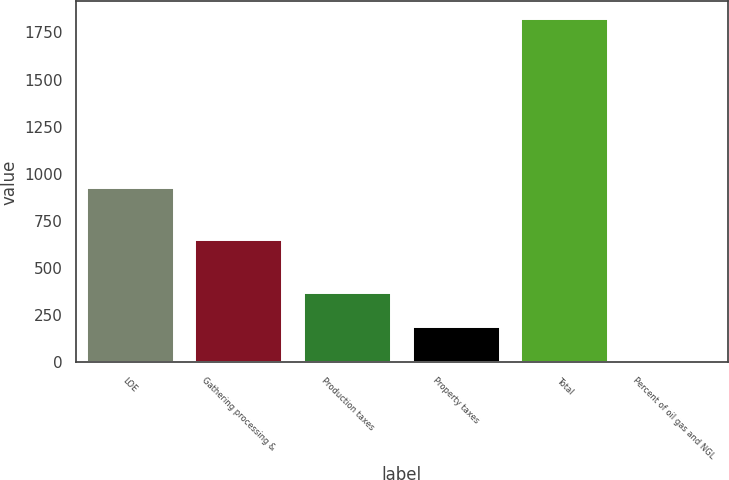Convert chart to OTSL. <chart><loc_0><loc_0><loc_500><loc_500><bar_chart><fcel>LOE<fcel>Gathering processing &<fcel>Production taxes<fcel>Property taxes<fcel>Total<fcel>Percent of oil gas and NGL<nl><fcel>927<fcel>647<fcel>367.64<fcel>185.72<fcel>1823<fcel>3.8<nl></chart> 